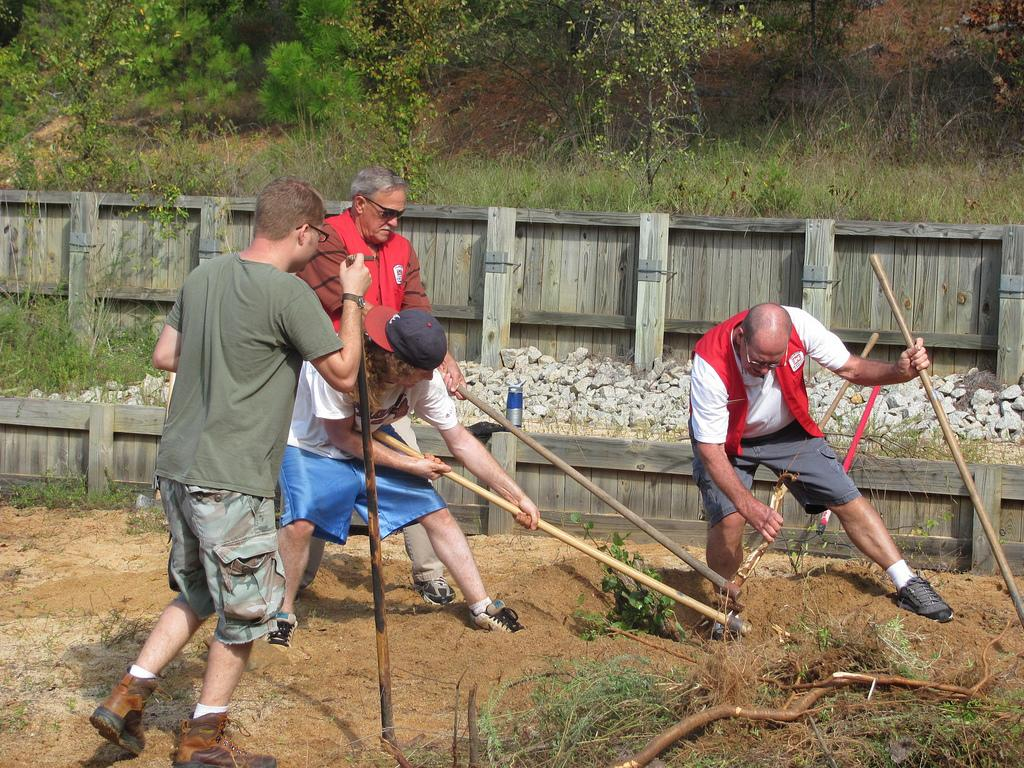How many people are in the image? There are four men in the image. What are the men doing in the image? The men are digging soil with sticks. What can be seen behind the men in the image? There is a wooden fence in the image. What is located in front of the wooden fence? Rocks are present in front of the wooden fence. What type of vegetation is visible in the image? There are plants in the image. What is the natural ground cover visible in the image? Grass is visible on the land. What type of soup is being served in the image? There is no soup present in the image; it features four men digging soil with sticks. What payment method is accepted for the services provided in the image? There is no payment method mentioned or implied in the image, as it focuses on the men digging soil with sticks. 